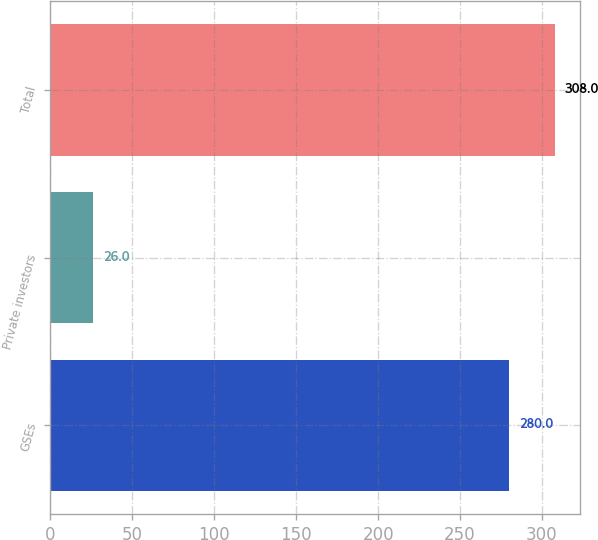<chart> <loc_0><loc_0><loc_500><loc_500><bar_chart><fcel>GSEs<fcel>Private investors<fcel>Total<nl><fcel>280<fcel>26<fcel>308<nl></chart> 